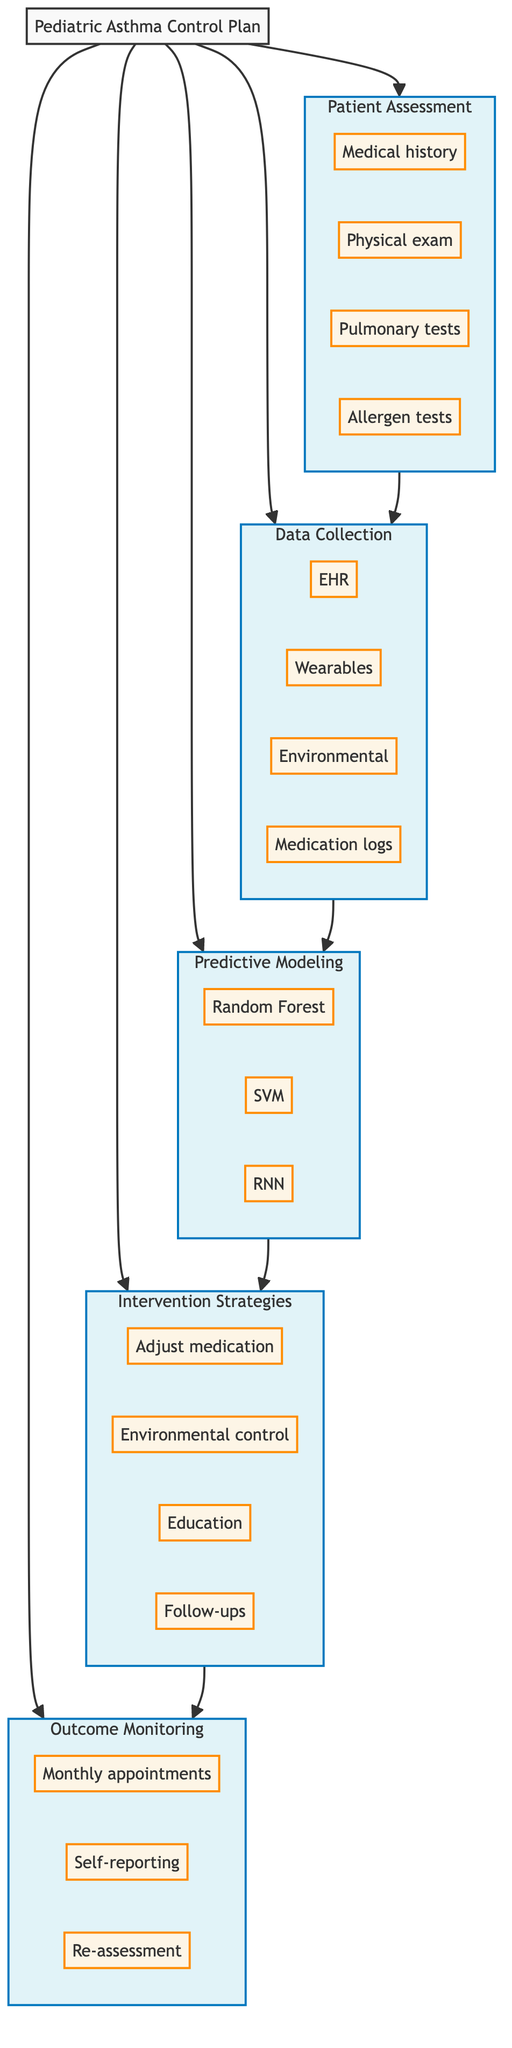What is the goal of the pathway? The introduction section states the goal is to enhance asthma management in pediatric patients using predictive analytics.
Answer: Enhance asthma management How many components are there in this clinical pathway? By listing the components shown in the diagram, we can count five components: Patient Assessment, Data Collection, Predictive Modeling, Intervention Strategies, and Outcome Monitoring.
Answer: Five Name one source of data collection. The data collection component provides multiple sources, one of which is Electronic Health Records (EHR).
Answer: Electronic Health Records Which predictive modeling method focuses on historical data patterns? Among the listed predictive modeling methods, the Random Forest method is known for utilizing historical data patterns effectively.
Answer: Random Forest How does Patient Assessment relate to Data Collection? The flow indicates a directional relationship where Patient Assessment provides the necessary information for Data Collection to proceed.
Answer: Provides information List one action in the Intervention Strategies. The intervention strategies component includes several actions; one example is adjusting medication dosage.
Answer: Adjust medication dosage How are interventions monitored over time? The outcome monitoring component details that effectiveness is determined through monthly follow-up appointments, patient self-reporting, and periodic re-assessment.
Answer: Monthly follow-up appointments What type of data is gathered from wearable devices? The Data Collection component mentions wearable devices as a source of data, typically gathering real-time health information related to asthma management.
Answer: Real-time health information How many types of predictive modeling methods are specified? The Predictive Modeling section specifies three methods: Random Forest, Support Vector Machine (SVM), and Recurrent Neural Networks (RNN), providing a total of three methods.
Answer: Three methods 